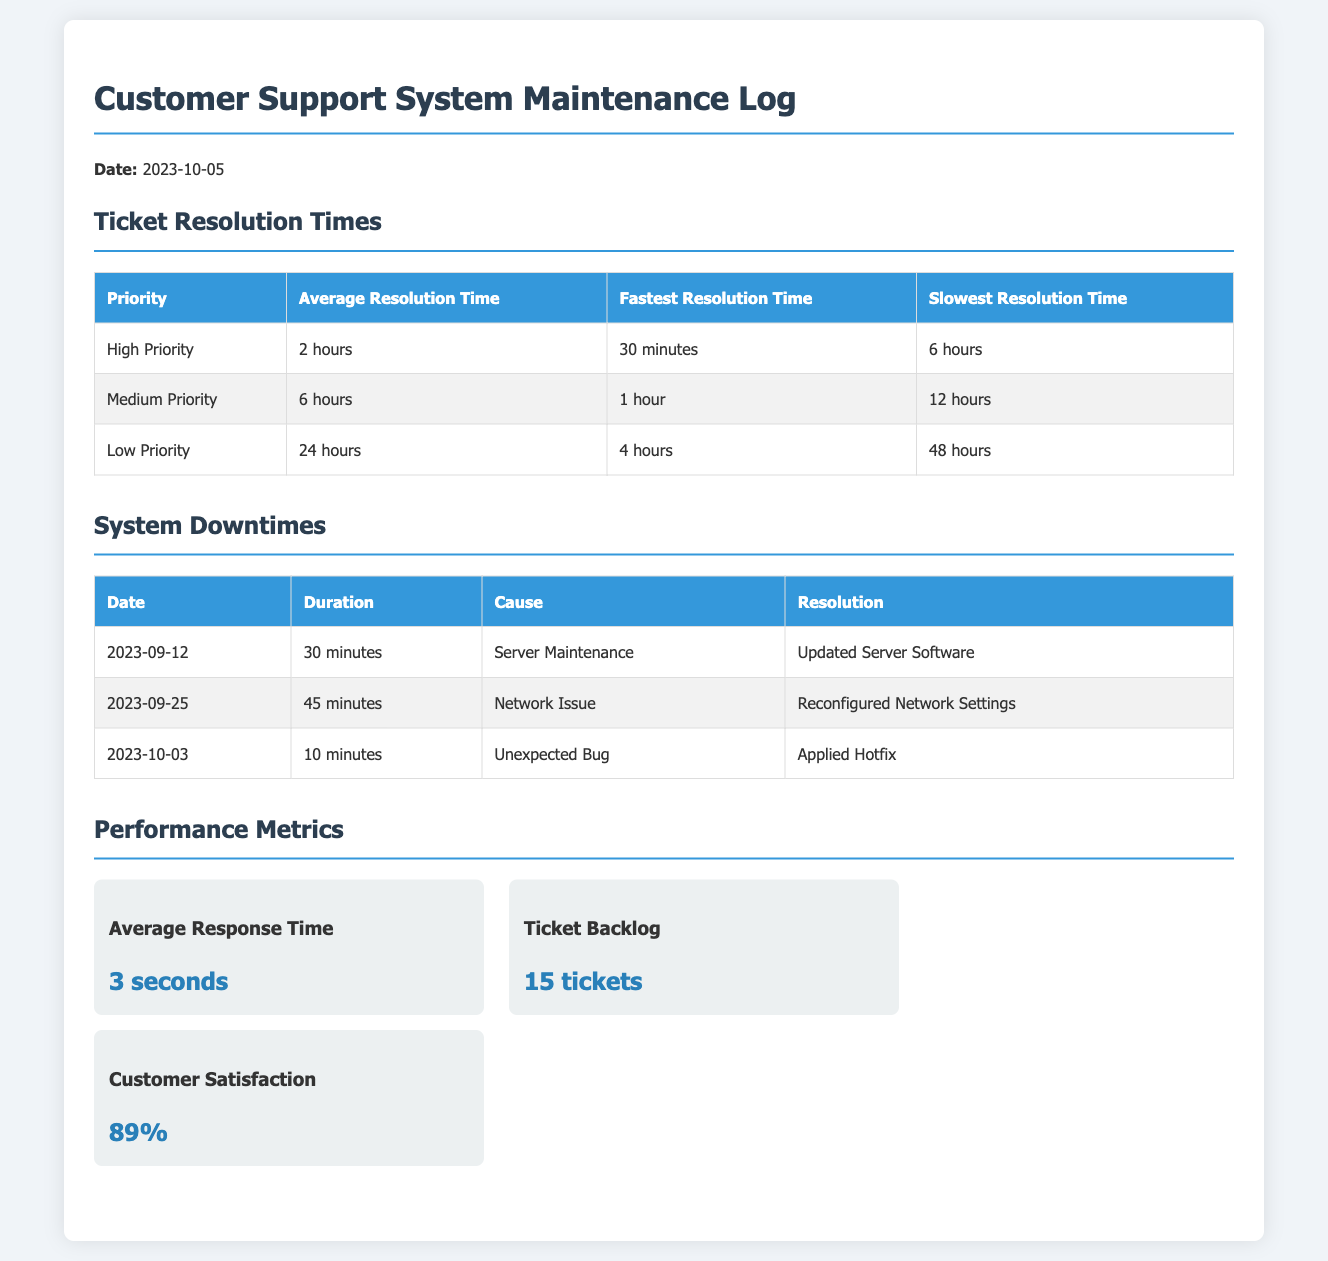What is the average resolution time for high priority tickets? The average resolution time for high priority tickets is provided in the table under Ticket Resolution Times.
Answer: 2 hours What was the cause of the downtimes on September 25? The cause of the downtimes is listed in the System Downtimes section with the date specified.
Answer: Network Issue What is the fastest resolution time for medium priority tickets? This information is specified under the Medium Priority section in the Ticket Resolution Times table.
Answer: 1 hour What is the duration of the downtime on October 3? The duration for that downtime is recorded in the System Downtimes table.
Answer: 10 minutes What is the customer satisfaction percentage? The customer satisfaction percentage is mentioned in the Performance Metrics section as a metric value.
Answer: 89% What was resolved during the server maintenance on September 12? The resolution for that downtime is specified in the System Downtimes table.
Answer: Updated Server Software What is the average response time? The average response time is provided as a metric in the Performance Metrics section of the document.
Answer: 3 seconds What is the total number of tickets in the backlog? The ticket backlog count is listed under the Performance Metrics section.
Answer: 15 tickets What was the slowest resolution time for low priority tickets? This information is found in the Ticket Resolution Times table under the Low Priority section.
Answer: 48 hours 